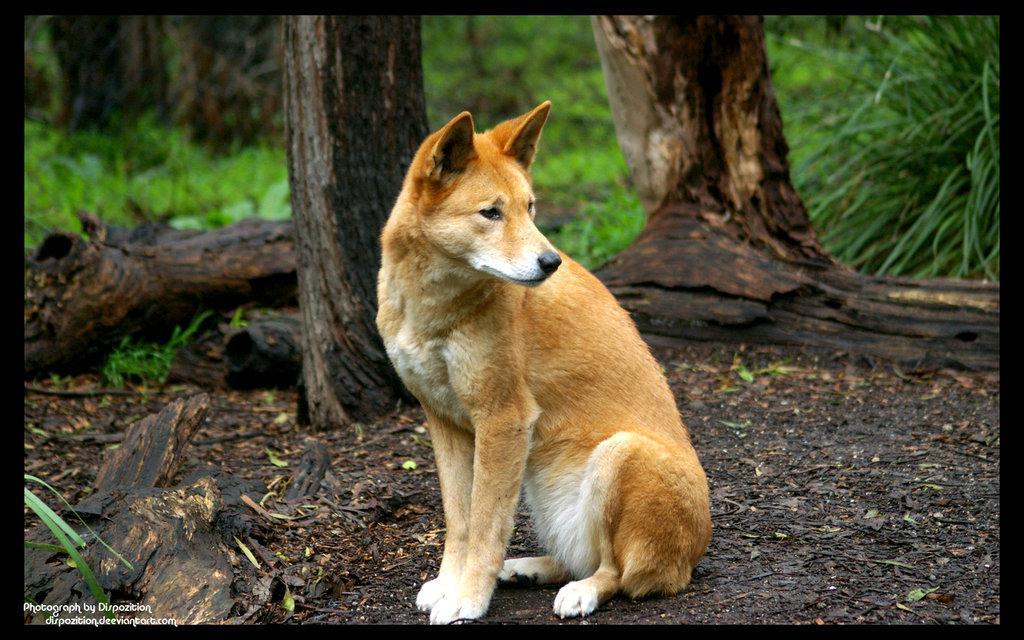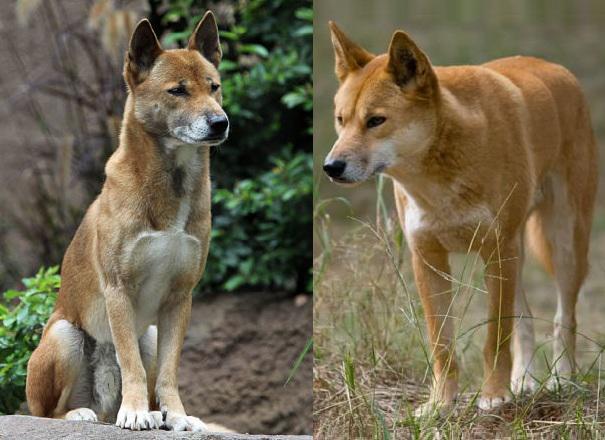The first image is the image on the left, the second image is the image on the right. Assess this claim about the two images: "There are exactly two canines, outdoors.". Correct or not? Answer yes or no. No. 